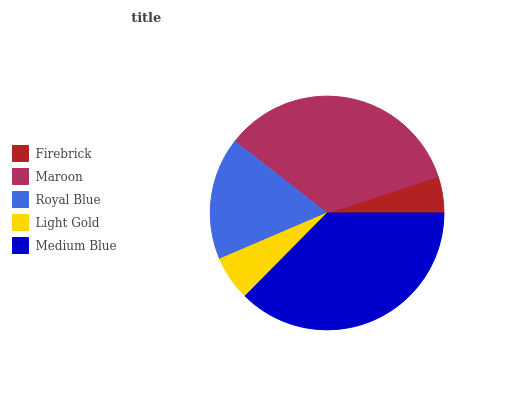Is Firebrick the minimum?
Answer yes or no. Yes. Is Medium Blue the maximum?
Answer yes or no. Yes. Is Maroon the minimum?
Answer yes or no. No. Is Maroon the maximum?
Answer yes or no. No. Is Maroon greater than Firebrick?
Answer yes or no. Yes. Is Firebrick less than Maroon?
Answer yes or no. Yes. Is Firebrick greater than Maroon?
Answer yes or no. No. Is Maroon less than Firebrick?
Answer yes or no. No. Is Royal Blue the high median?
Answer yes or no. Yes. Is Royal Blue the low median?
Answer yes or no. Yes. Is Maroon the high median?
Answer yes or no. No. Is Maroon the low median?
Answer yes or no. No. 